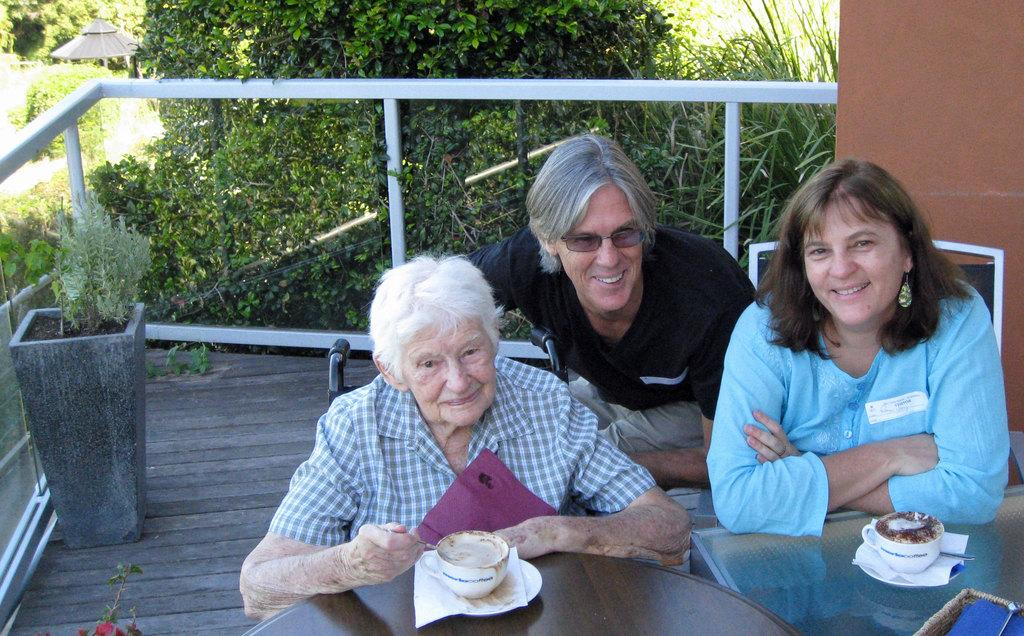How many people are sitting on chairs in the image? There are three persons sitting on chairs in the image. What is the woman holding in her hand? The woman is holding a spoon. What items can be seen on the table? There are cups, saucers, and tissue papers on the table. What can be seen in the background of the image? There are trees, a plant, and a wall in the background. What type of fuel is being used on the stage in the image? There is no stage or fuel present in the image. 